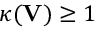Convert formula to latex. <formula><loc_0><loc_0><loc_500><loc_500>\kappa ( V ) \geq 1</formula> 